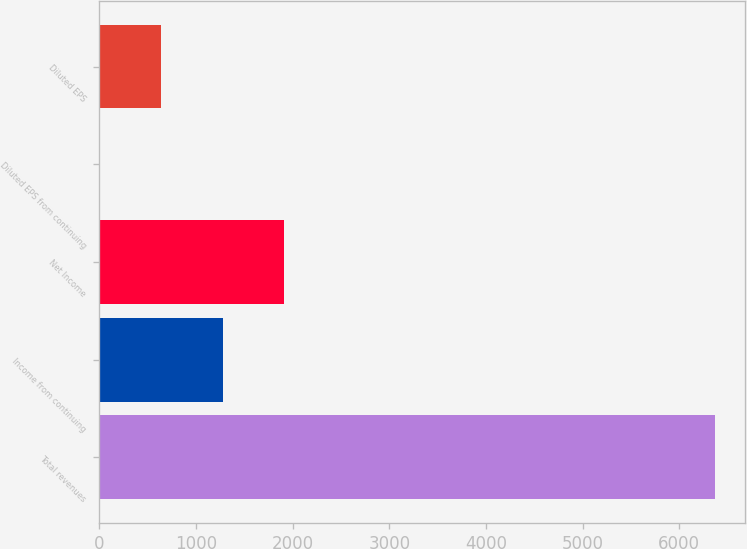<chart> <loc_0><loc_0><loc_500><loc_500><bar_chart><fcel>Total revenues<fcel>Income from continuing<fcel>Net Income<fcel>Diluted EPS from continuing<fcel>Diluted EPS<nl><fcel>6366<fcel>1275.18<fcel>1911.53<fcel>2.48<fcel>638.83<nl></chart> 